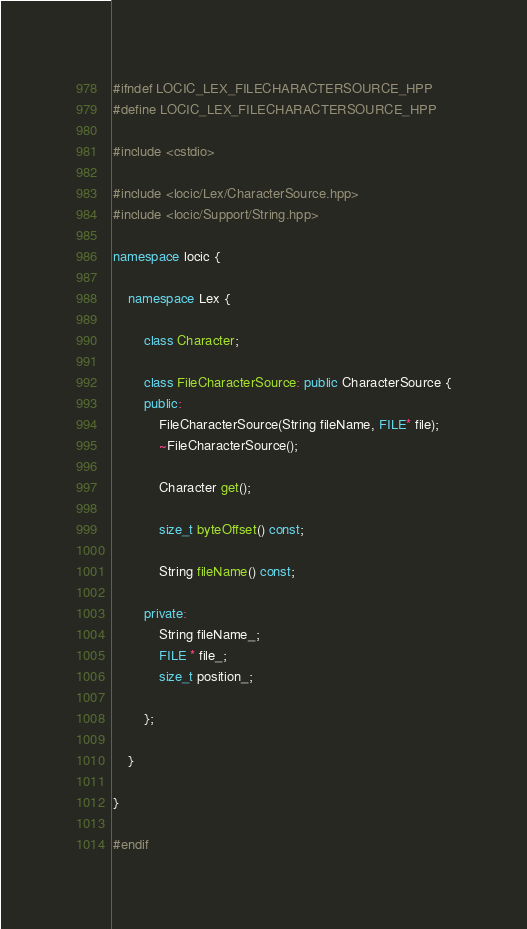Convert code to text. <code><loc_0><loc_0><loc_500><loc_500><_C++_>#ifndef LOCIC_LEX_FILECHARACTERSOURCE_HPP
#define LOCIC_LEX_FILECHARACTERSOURCE_HPP

#include <cstdio>

#include <locic/Lex/CharacterSource.hpp>
#include <locic/Support/String.hpp>

namespace locic {
	
	namespace Lex {
		
		class Character;
		
		class FileCharacterSource: public CharacterSource {
		public:
			FileCharacterSource(String fileName, FILE* file);
			~FileCharacterSource();
			
			Character get();
			
			size_t byteOffset() const;
			
			String fileName() const;
			
		private:
			String fileName_;
			FILE * file_;
			size_t position_;
			
		};
		
	}
	
}

#endif</code> 